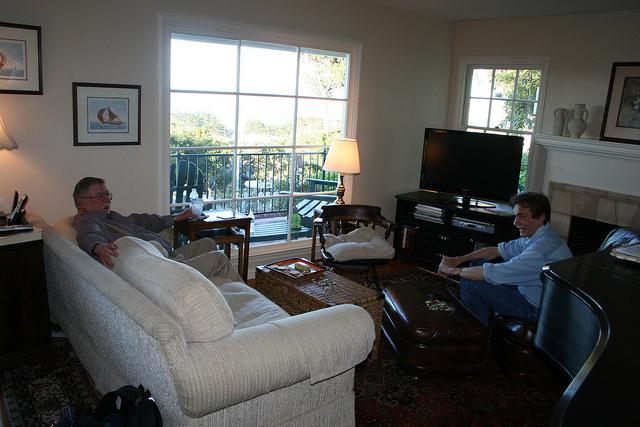What color is the couch?
Write a very short answer. White. Is this room overcrowded?
Write a very short answer. No. Is it day or night?
Short answer required. Day. Is there a window seat?
Be succinct. No. How many pictures are on the wall?
Be succinct. 3. What kind of pants is the man on the right wearing?
Keep it brief. Jeans. Is this house facing toward ocean?
Write a very short answer. No. Is the couch red?
Keep it brief. No. What scenery is outside his window?
Answer briefly. Trees. How many people are visible in this picture?
Short answer required. 2. How many pillows are in the picture?
Quick response, please. 1. Are any people seated on the couch?
Short answer required. Yes. Is the television on?
Keep it brief. No. What does the picture on the wall represent?
Be succinct. Boat. Is this a hotel room?
Give a very brief answer. No. Whose apt is this?
Short answer required. Man. Is there a desk in front of the window?
Write a very short answer. No. Is there a person standing in front of the television?
Keep it brief. No. Is there a woman in the room?
Quick response, please. No. What is the man doing?
Write a very short answer. Talking. What is the man currently doing in this picture?
Be succinct. Talking. Do the windows have blinds?
Concise answer only. No. 